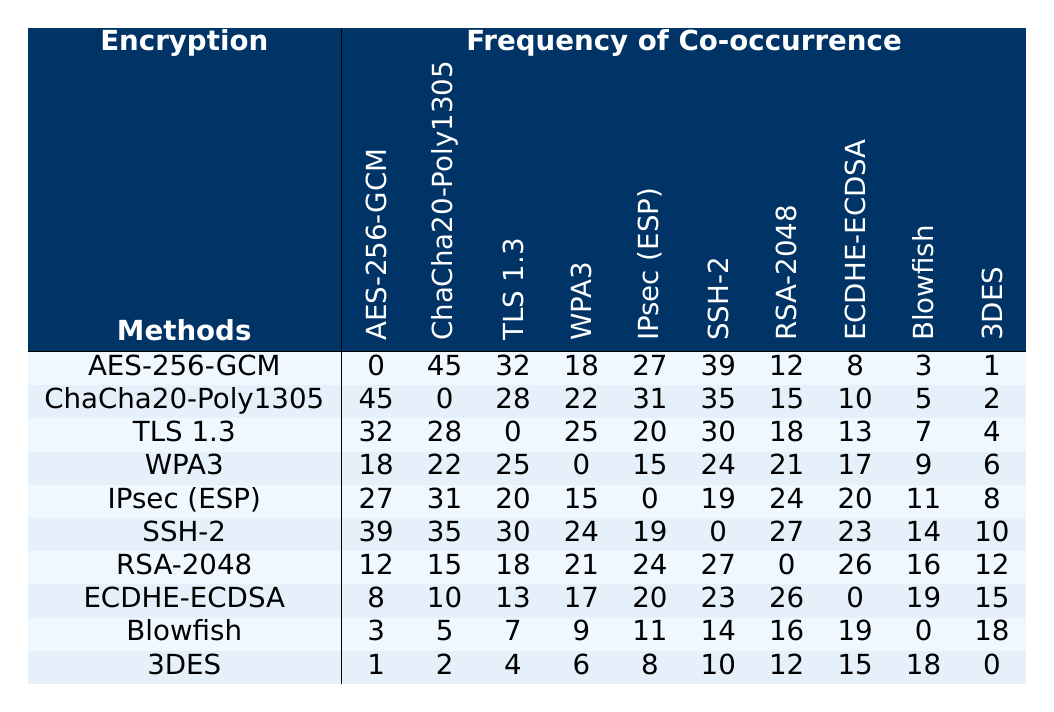What is the frequency of AES-256-GCM co-occurring with ChaCha20-Poly1305? Looking at the row corresponding to AES-256-GCM, the value under the column for ChaCha20-Poly1305 is 45.
Answer: 45 Which encryption method appears the least frequently with 3DES? For 3DES, we examine the last row and the corresponding column values to find the smallest. The smallest value (excluding itself) is 1 (with AES-256-GCM).
Answer: 1 What is the total frequency of co-occurrences for WPA3 with all other methods? Summing the values in the row for WPA3 gives: 18 (AES-256-GCM) + 22 (ChaCha20-Poly1305) + 25 (TLS 1.3) + 0 + 15 (IPsec) + 24 (SSH-2) + 21 (RSA-2048) + 17 (ECDHE-ECDSA) + 9 (Blowfish) + 6 (3DES) =  0 + 18 + 22 + 25 + 15 + 24 + 21 + 17 + 9 + 6 = 137.
Answer: 137 Is the frequency between ChaCha20-Poly1305 and RSA-2048 higher than between WPA3 and Blowfish? The frequency for ChaCha20-Poly1305 and RSA-2048 is 15, while for WPA3 and Blowfish is 9. Since 15 is greater than 9, the answer is yes.
Answer: Yes What is the average frequency of co-occurrences for IPsec (ESP) with all other methods? The values for IPsec (ESP) are 27 (AES-256-GCM), 31 (ChaCha20-Poly1305), 20 (TLS 1.3), 15 (WPA3), 0, 19 (SSH-2), 24 (RSA-2048), 20 (ECDHE-ECDSA), 11 (Blowfish), and 8 (3DES). Summing these gives: 27 + 31 + 20 + 15 + 0 + 19 + 24 + 20 + 11 + 8 =  4 + 27 + 31 + 20 + 15 + 0 + 19 + 24 + 20 + 11 + 8 = 3 = 204. There are 9 co-occurrences, so the average is 204/9 ≈ 22.67.
Answer: ≈ 22.67 Which has a higher co-occurrence frequency, SSH-2 with ECDHE-ECDSA, or ECDHE-ECDSA with Blowfish? Checking the frequency, SSH-2 has a value of 23 with ECDHE-ECDSA, and ECDHE-ECDSA has 19 with Blowfish. 23 is greater than 19, so SSH-2 co-occurs more frequently with ECDHE-ECDSA.
Answer: SSH-2 What is the co-occurrence frequency for the least common method with the second least common method? The least common method is 3DES (0) with all others. Therefore, no other method co-occurs with it, giving a total of 0.
Answer: 0 Comparing the highest frequency for network types, which encryption method shows the highest frequency of co-occurrence in the table? The highest frequency of co-occurrence in the table is 45 (between AES-256-GCM and ChaCha20-Poly1305).
Answer: AES-256-GCM What is the total number of times IPsec (ESP) has co-occurrences with all methods that have a frequency greater than 20? The values for IPsec (ESP) being higher than 20 with methods are: 27 (AES-256-GCM), 31 (ChaCha20-Poly1305), 24 (RSA-2048), and 24 (SSH-2). Summing only those values gives: 27 + 31 + 24 + 24 = 106.
Answer: 106 What is the difference in frequency between ChaCha20-Poly1305 and TLS 1.3 for the co-occurrence with WPA3? The frequency of ChaCha20-Poly1305 with WPA3 is 22 and TLS 1.3 with WPA3 gives 25. The difference is 25 - 22 = 3.
Answer: 3 